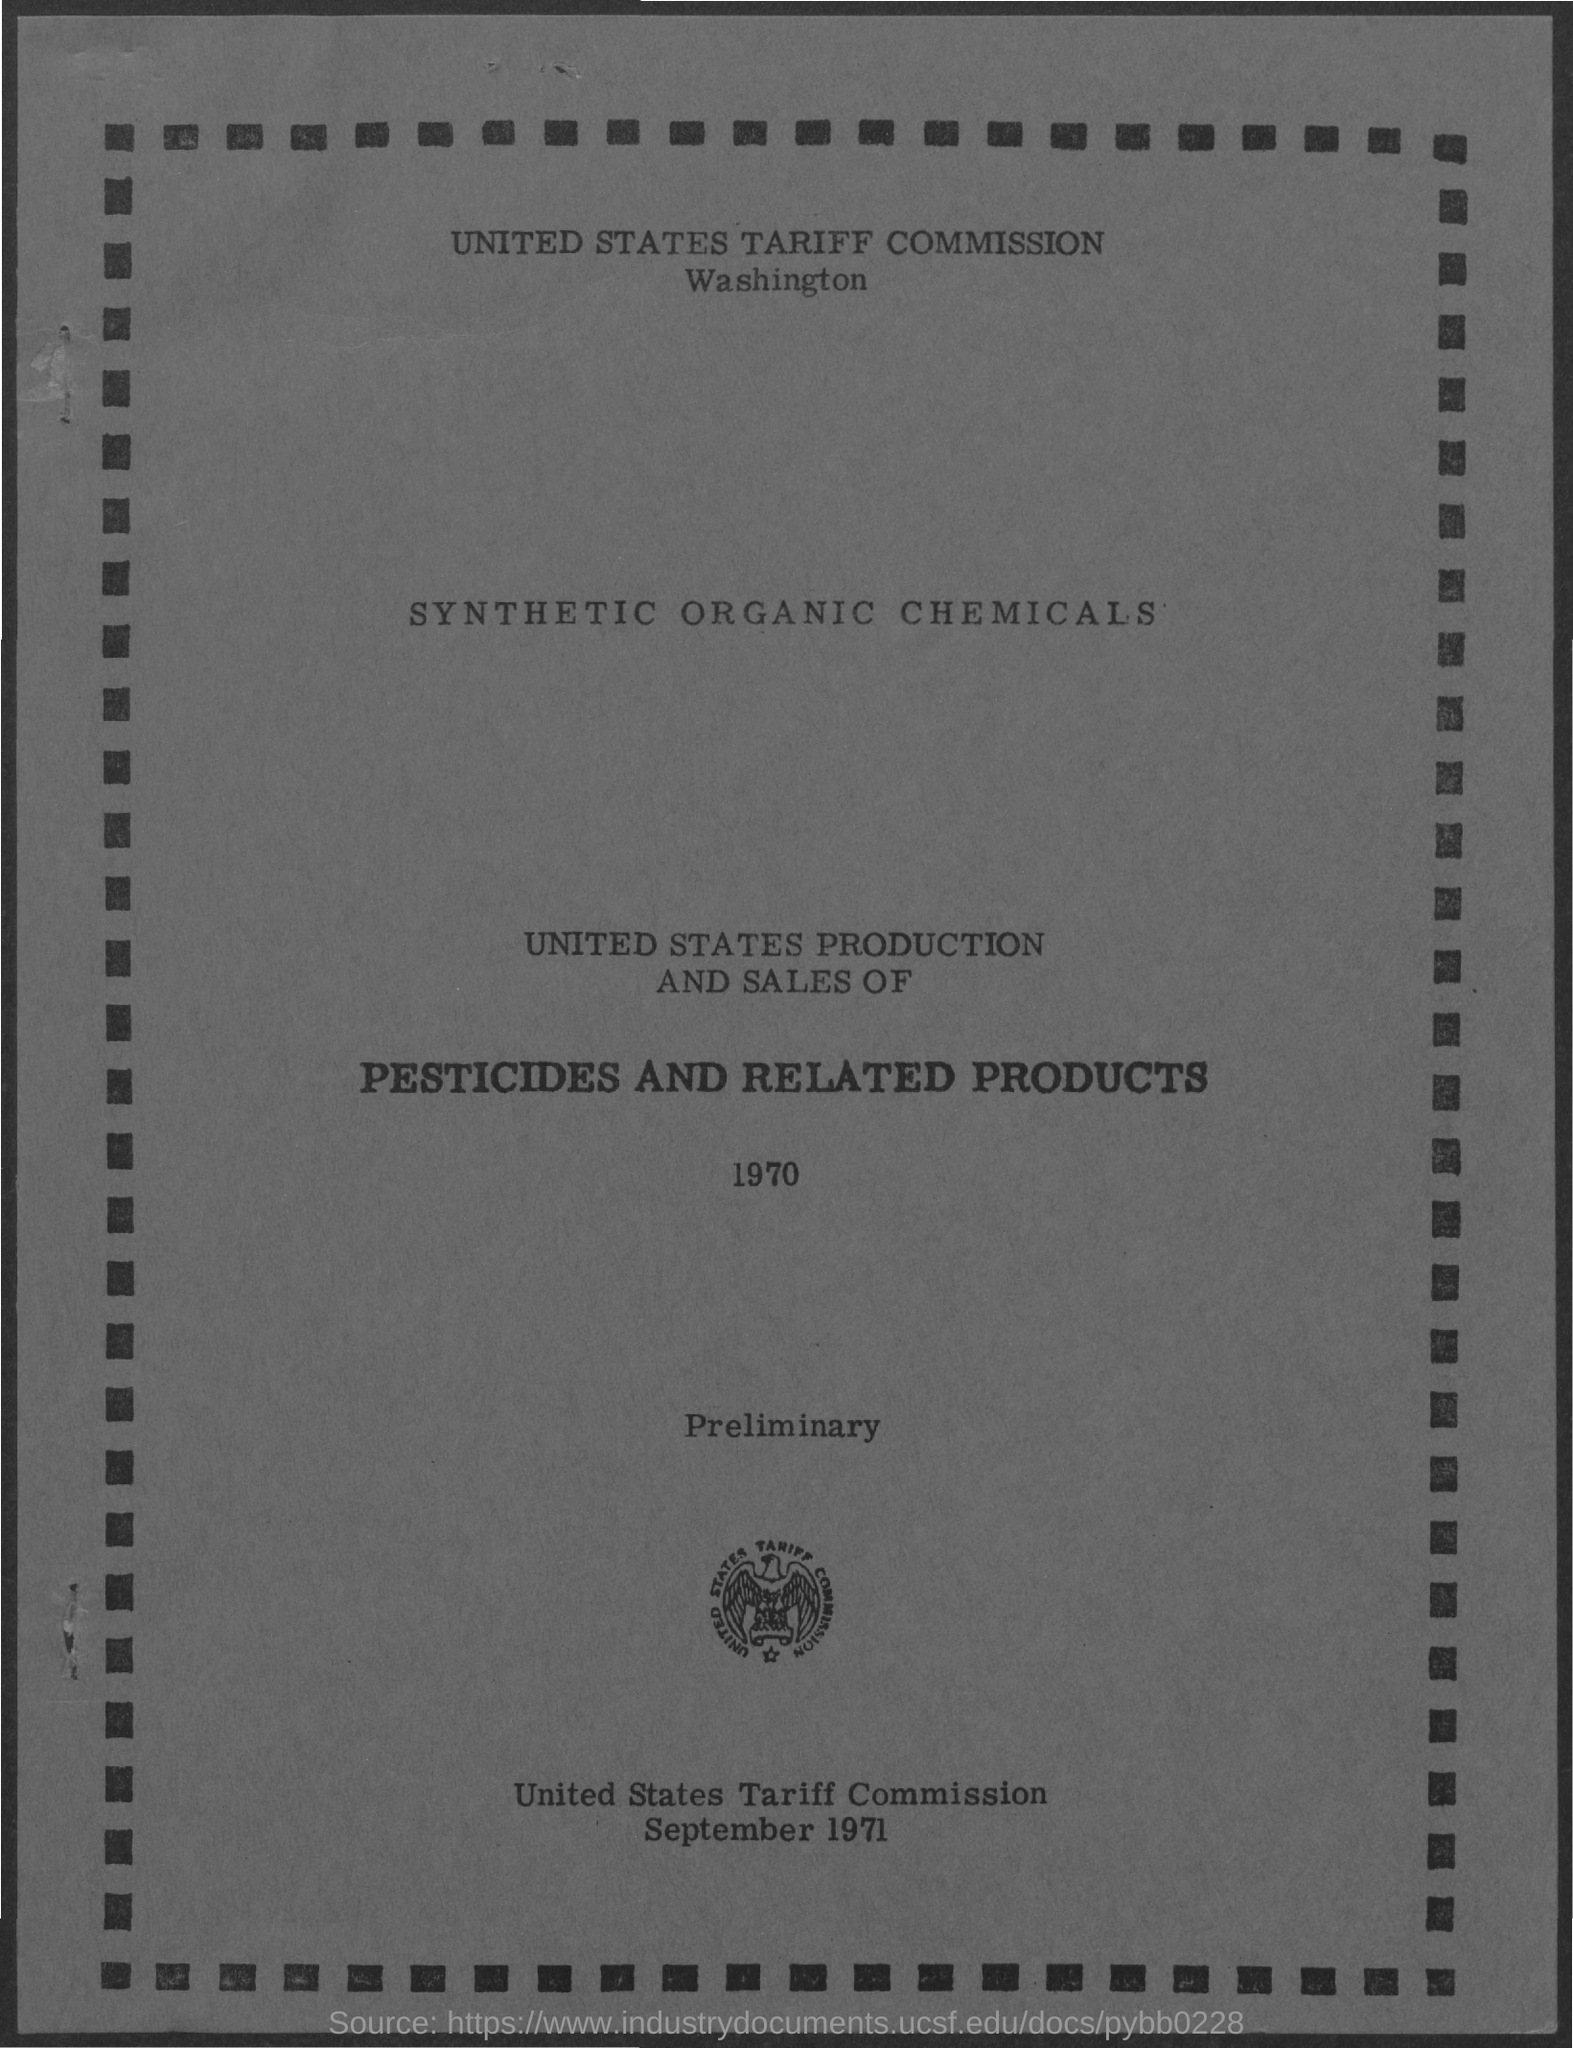What is the first title in the document?
Offer a terse response. United States Tariff Commission. 